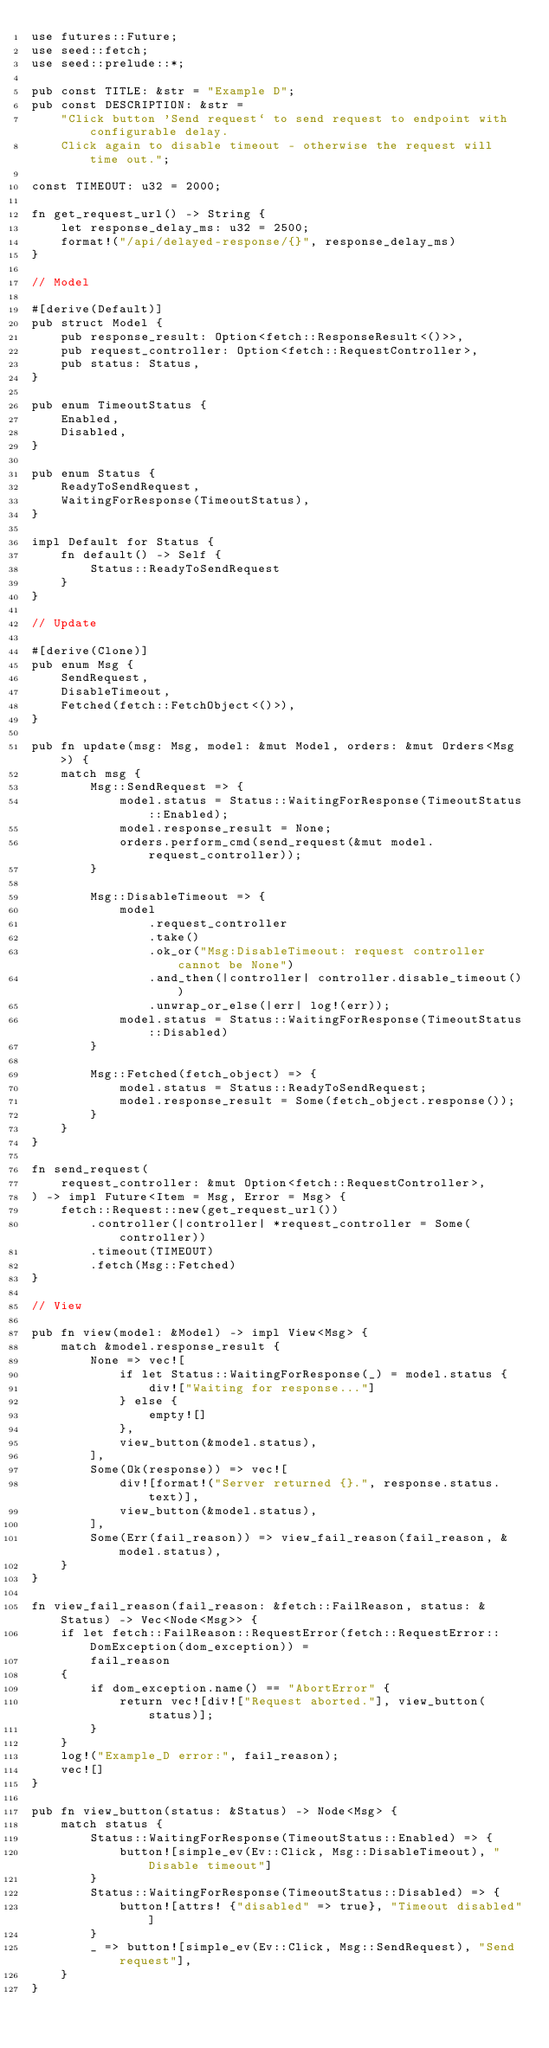Convert code to text. <code><loc_0><loc_0><loc_500><loc_500><_Rust_>use futures::Future;
use seed::fetch;
use seed::prelude::*;

pub const TITLE: &str = "Example D";
pub const DESCRIPTION: &str =
    "Click button 'Send request` to send request to endpoint with configurable delay.
    Click again to disable timeout - otherwise the request will time out.";

const TIMEOUT: u32 = 2000;

fn get_request_url() -> String {
    let response_delay_ms: u32 = 2500;
    format!("/api/delayed-response/{}", response_delay_ms)
}

// Model

#[derive(Default)]
pub struct Model {
    pub response_result: Option<fetch::ResponseResult<()>>,
    pub request_controller: Option<fetch::RequestController>,
    pub status: Status,
}

pub enum TimeoutStatus {
    Enabled,
    Disabled,
}

pub enum Status {
    ReadyToSendRequest,
    WaitingForResponse(TimeoutStatus),
}

impl Default for Status {
    fn default() -> Self {
        Status::ReadyToSendRequest
    }
}

// Update

#[derive(Clone)]
pub enum Msg {
    SendRequest,
    DisableTimeout,
    Fetched(fetch::FetchObject<()>),
}

pub fn update(msg: Msg, model: &mut Model, orders: &mut Orders<Msg>) {
    match msg {
        Msg::SendRequest => {
            model.status = Status::WaitingForResponse(TimeoutStatus::Enabled);
            model.response_result = None;
            orders.perform_cmd(send_request(&mut model.request_controller));
        }

        Msg::DisableTimeout => {
            model
                .request_controller
                .take()
                .ok_or("Msg:DisableTimeout: request controller cannot be None")
                .and_then(|controller| controller.disable_timeout())
                .unwrap_or_else(|err| log!(err));
            model.status = Status::WaitingForResponse(TimeoutStatus::Disabled)
        }

        Msg::Fetched(fetch_object) => {
            model.status = Status::ReadyToSendRequest;
            model.response_result = Some(fetch_object.response());
        }
    }
}

fn send_request(
    request_controller: &mut Option<fetch::RequestController>,
) -> impl Future<Item = Msg, Error = Msg> {
    fetch::Request::new(get_request_url())
        .controller(|controller| *request_controller = Some(controller))
        .timeout(TIMEOUT)
        .fetch(Msg::Fetched)
}

// View

pub fn view(model: &Model) -> impl View<Msg> {
    match &model.response_result {
        None => vec![
            if let Status::WaitingForResponse(_) = model.status {
                div!["Waiting for response..."]
            } else {
                empty![]
            },
            view_button(&model.status),
        ],
        Some(Ok(response)) => vec![
            div![format!("Server returned {}.", response.status.text)],
            view_button(&model.status),
        ],
        Some(Err(fail_reason)) => view_fail_reason(fail_reason, &model.status),
    }
}

fn view_fail_reason(fail_reason: &fetch::FailReason, status: &Status) -> Vec<Node<Msg>> {
    if let fetch::FailReason::RequestError(fetch::RequestError::DomException(dom_exception)) =
        fail_reason
    {
        if dom_exception.name() == "AbortError" {
            return vec![div!["Request aborted."], view_button(status)];
        }
    }
    log!("Example_D error:", fail_reason);
    vec![]
}

pub fn view_button(status: &Status) -> Node<Msg> {
    match status {
        Status::WaitingForResponse(TimeoutStatus::Enabled) => {
            button![simple_ev(Ev::Click, Msg::DisableTimeout), "Disable timeout"]
        }
        Status::WaitingForResponse(TimeoutStatus::Disabled) => {
            button![attrs! {"disabled" => true}, "Timeout disabled"]
        }
        _ => button![simple_ev(Ev::Click, Msg::SendRequest), "Send request"],
    }
}
</code> 